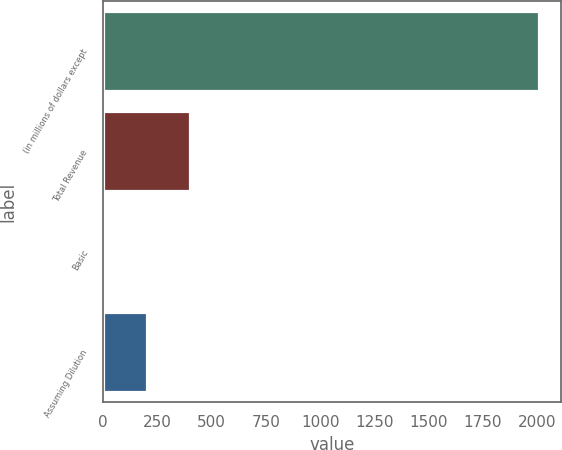Convert chart to OTSL. <chart><loc_0><loc_0><loc_500><loc_500><bar_chart><fcel>(in millions of dollars except<fcel>Total Revenue<fcel>Basic<fcel>Assuming Dilution<nl><fcel>2007<fcel>401.42<fcel>0.02<fcel>200.72<nl></chart> 